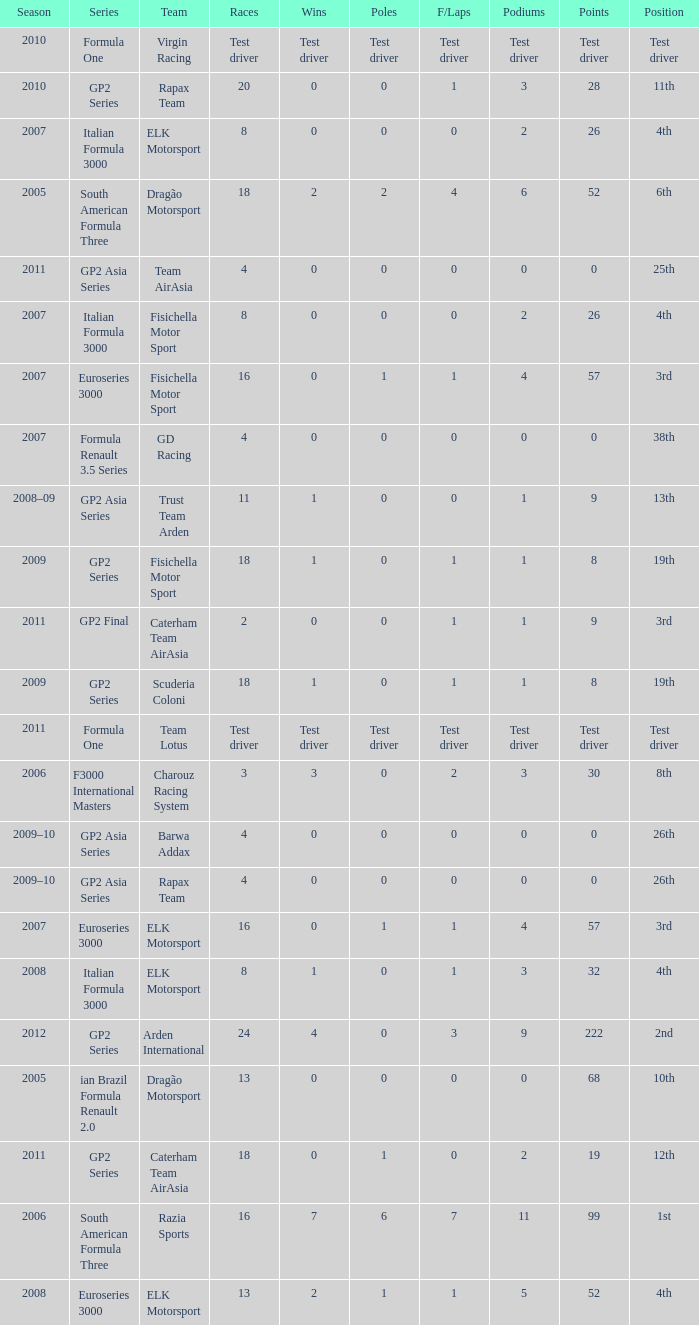In which season did he have 0 Poles and 19th position in the GP2 Series? 2009, 2009. 